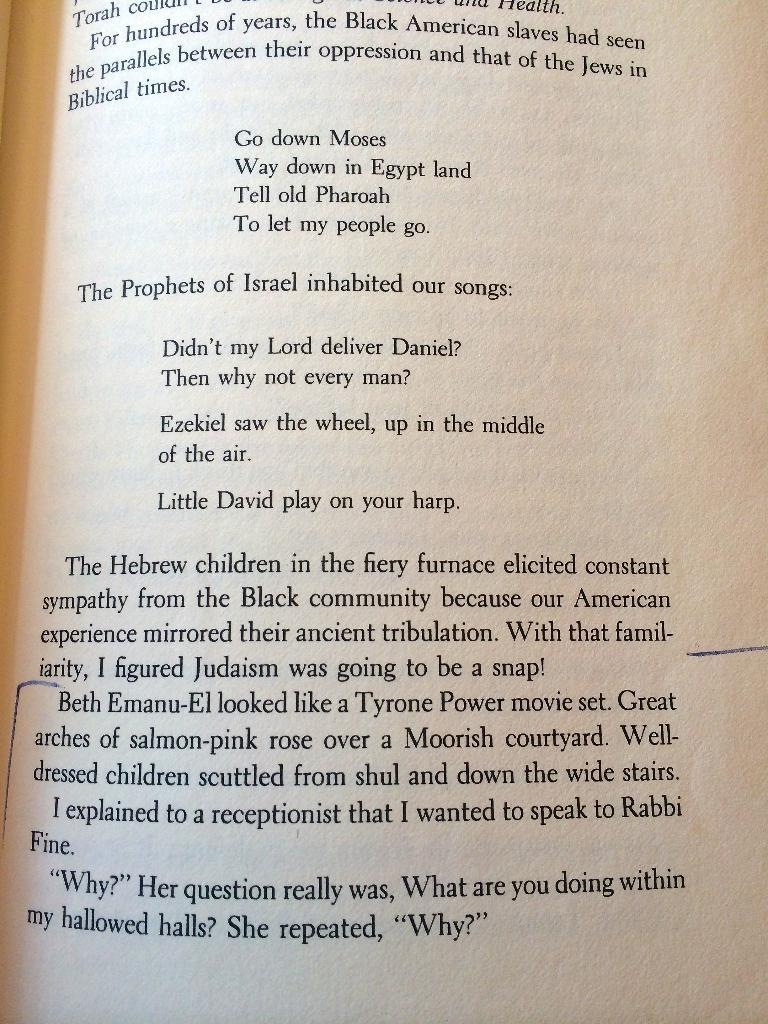<image>
Relay a brief, clear account of the picture shown. An open page of the book ends with a receptionist repeating the question "Why?". 